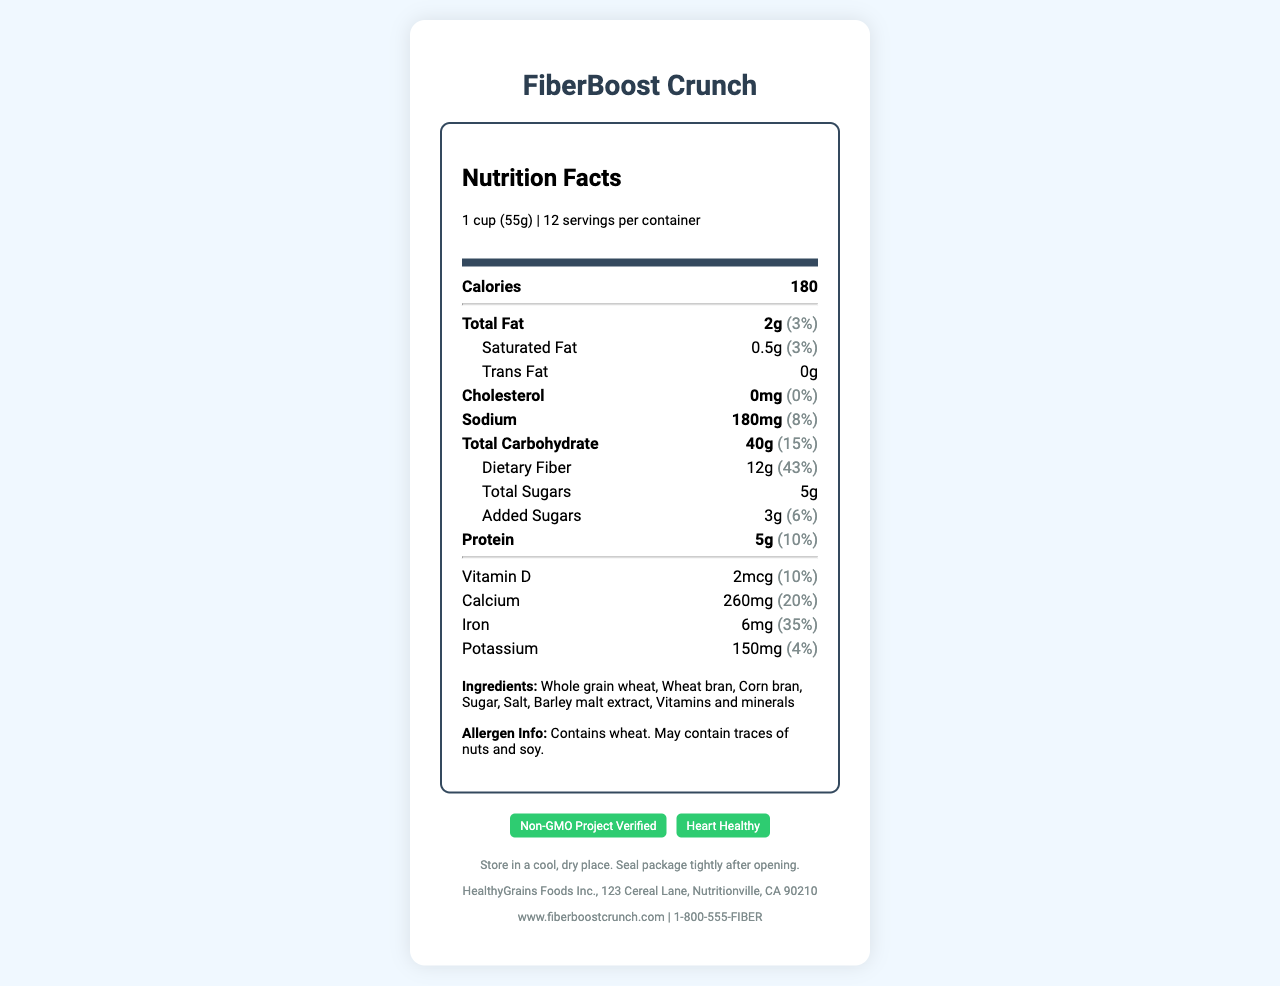what is the serving size for FiberBoost Crunch? The serving size is listed at the top of the label under the "Nutrition Facts" section.
Answer: 1 cup (55g) how many calories are in one serving? Under the "Nutrition Facts" section, the calories per serving are mentioned right below the serving size information.
Answer: 180 what is the daily value percentage for dietary fiber per serving? Under the "Total Carbohydrate" section, "Dietary Fiber" is listed with a daily value percentage of 43%.
Answer: 43% which ingredient is listed first on the label? The list of ingredients starts with "Whole grain wheat" which is the first ingredient mentioned.
Answer: Whole grain wheat what certifications does FiberBoost Crunch have? The certifications are shown at the bottom of the label in a separate section.
Answer: Non-GMO Project Verified, Heart Healthy how much sodium is in one serving? The "Sodium" section specifies that there are 180mg of sodium per serving.
Answer: 180mg what is the total carbohydrate content per serving? The "Total Carbohydrate" section shows that there are 40g of carbs in each serving.
Answer: 40g how many grams of added sugars are there per serving? The "Added Sugars" section mentions that there are 3g of added sugars.
Answer: 3g what is the daily value percentage for calcium per serving? Under the "Vitamin and Minerals" section, the daily value percentage for calcium is listed as 20%.
Answer: 20% which of the following nutrients has the highest daily value percentage per serving? A. Vitamin D B. Iron C. Protein D. Potassium Iron has a daily value percentage of 35%, which is the highest compared to the other listed nutrients.
Answer: B. Iron what is the fat content per serving? A. 0.5g B. 1g C. 2g D. 3g The "Total Fat" section shows that there are 2g of fat per serving.
Answer: C. 2g is there any cholesterol in FiberBoost Crunch? The "Cholesterol" section lists 0mg, indicating that there is no cholesterol in the cereal.
Answer: No describe the main idea of the document The document is a nutrition facts label that breaks down the essential nutrients and their respective daily value percentages for FiberBoost Crunch cereal. It also lists the ingredients, potential allergens, certifications, storage instructions, and contact information for the manufacturer.
Answer: The document provides detailed nutrition information about FiberBoost Crunch, a high-fiber cereal, including serving size, nutrients, daily value percentages, ingredients, allergen information, certifications, storage instructions, and manufacturer details. what are the health benefits of FiberBoost Crunch? The document lists the nutritional content and certifications but does not explicitly describe the health benefits of the product.
Answer: Not enough information 